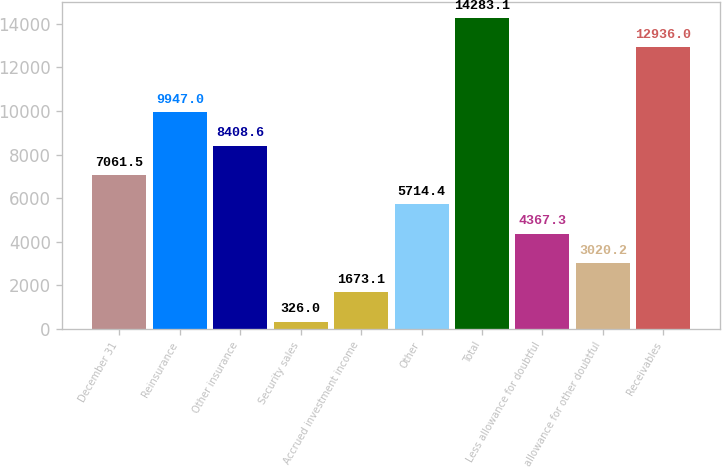Convert chart. <chart><loc_0><loc_0><loc_500><loc_500><bar_chart><fcel>December 31<fcel>Reinsurance<fcel>Other insurance<fcel>Security sales<fcel>Accrued investment income<fcel>Other<fcel>Total<fcel>Less allowance for doubtful<fcel>allowance for other doubtful<fcel>Receivables<nl><fcel>7061.5<fcel>9947<fcel>8408.6<fcel>326<fcel>1673.1<fcel>5714.4<fcel>14283.1<fcel>4367.3<fcel>3020.2<fcel>12936<nl></chart> 